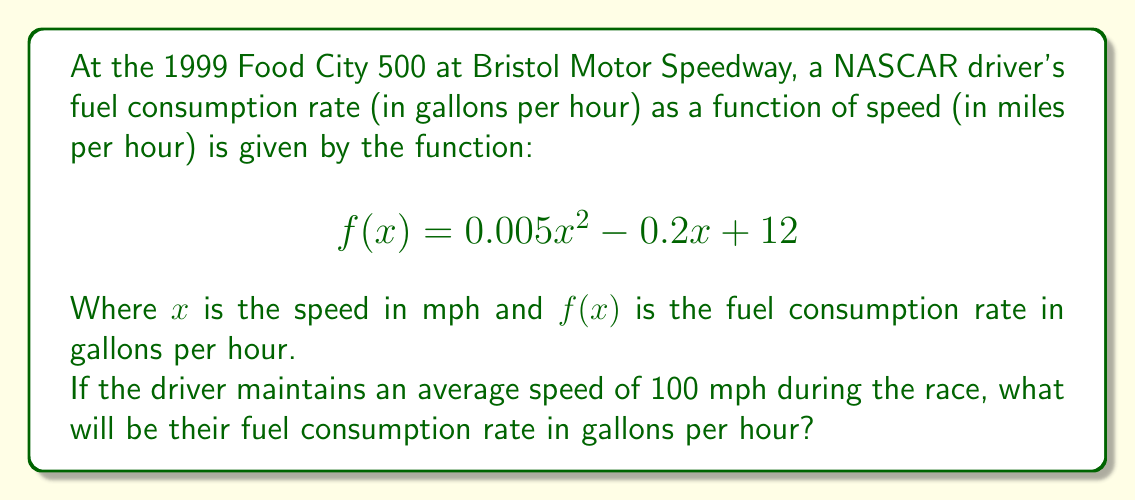Teach me how to tackle this problem. To solve this problem, we need to evaluate the function $f(x)$ at $x = 100$ mph. Let's break it down step-by-step:

1) We're given the function:
   $$f(x) = 0.005x^2 - 0.2x + 12$$

2) We need to find $f(100)$, so let's substitute $x = 100$ into the function:
   $$f(100) = 0.005(100)^2 - 0.2(100) + 12$$

3) Let's evaluate each term:
   - $0.005(100)^2 = 0.005(10000) = 50$
   - $-0.2(100) = -20$
   - $12$ remains as is

4) Now, let's sum these terms:
   $$f(100) = 50 - 20 + 12 = 42$$

Therefore, at a speed of 100 mph, the fuel consumption rate will be 42 gallons per hour.
Answer: 42 gallons per hour 